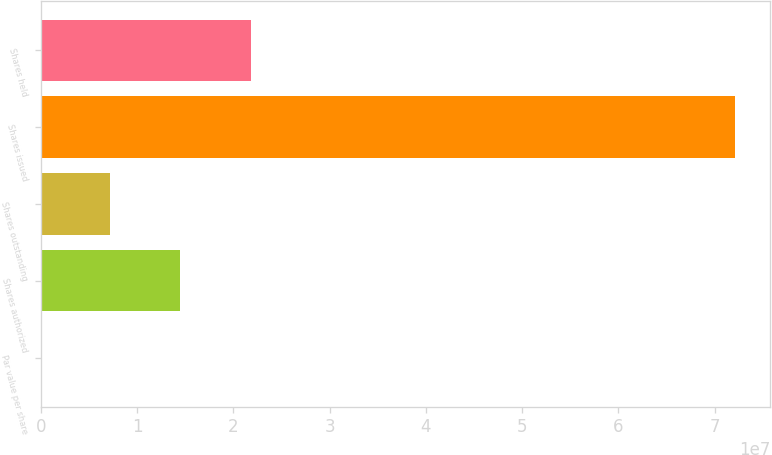Convert chart. <chart><loc_0><loc_0><loc_500><loc_500><bar_chart><fcel>Par value per share<fcel>Shares authorized<fcel>Shares outstanding<fcel>Shares issued<fcel>Shares held<nl><fcel>0.01<fcel>1.44304e+07<fcel>7.21519e+06<fcel>7.21519e+07<fcel>2.18023e+07<nl></chart> 